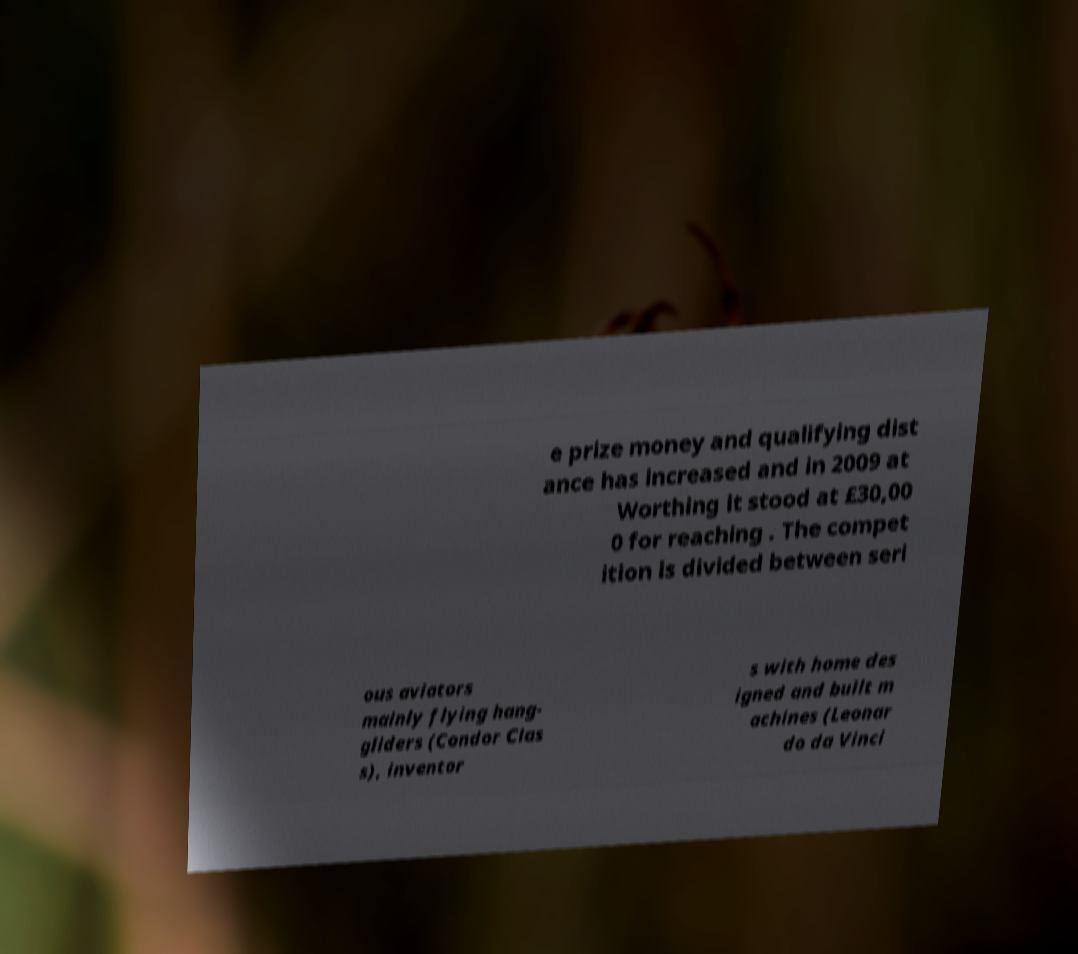Can you read and provide the text displayed in the image?This photo seems to have some interesting text. Can you extract and type it out for me? e prize money and qualifying dist ance has increased and in 2009 at Worthing it stood at £30,00 0 for reaching . The compet ition is divided between seri ous aviators mainly flying hang- gliders (Condor Clas s), inventor s with home des igned and built m achines (Leonar do da Vinci 